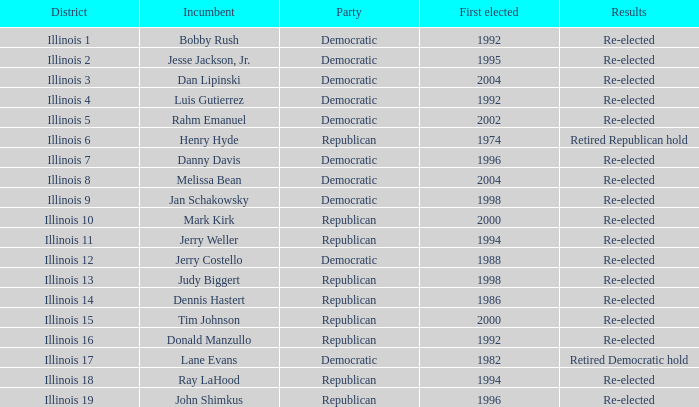What is Illinois 13 District's Party? Republican. 